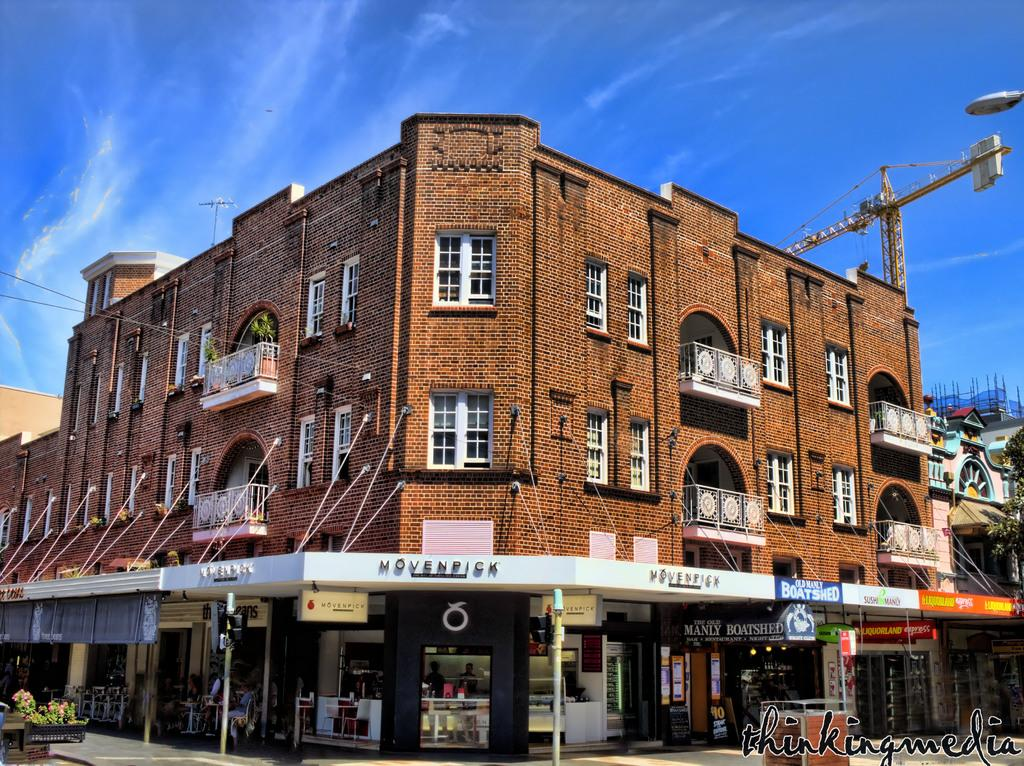What type of structures can be seen in the image? There are buildings in the image. What are the poles used for in the image? The purpose of the poles is not specified in the image. What is located at the bottom of the image? There are stores and boards at the bottom of the image. Where is the tree situated in the image? The tree is on the left side of the image. What can be seen in the background of the image? The sky and a crane are visible in the background of the image. What is the taste of the crow in the image? There is no crow present in the image, so it is not possible to determine its taste. What territory does the tree in the image belong to? The image does not provide information about the tree's territory. 